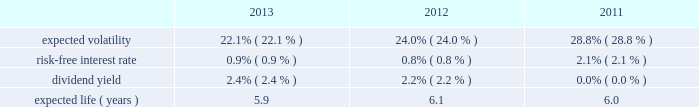Portion of the death benefits directly from the insurance company and the company receives the remainder of the death benefits .
It is currently expected that minimal cash payments will be required to fund these policies .
The net periodic pension cost for these split-dollar life insurance arrangements was $ 5 million for the years ended december 31 , 2013 , 2012 and 2011 .
The company has recorded a liability representing the actuarial present value of the future death benefits as of the employees 2019 expected retirement date of $ 51 million and $ 58 million as of december 31 , 2013 and december 31 , 2012 , respectively .
Deferred compensation plan the company amended and reinstated its deferred compensation plan ( 201cthe plan 201d ) effective june 1 , 2013 to reopen the plan to certain participants .
Under the plan , participating executives may elect to defer base salary and cash incentive compensation in excess of 401 ( k ) plan limitations .
Participants under the plan may choose to invest their deferred amounts in the same investment alternatives available under the company's 401 ( k ) plan .
The plan also allows for company matching contributions for the following : ( i ) the first 4% ( 4 % ) of compensation deferred under the plan , subject to a maximum of $ 50000 for board officers , ( ii ) lost matching amounts that would have been made under the 401 ( k ) plan if participants had not participated in the plan , and ( iii ) discretionary amounts as approved by the compensation and leadership committee of the board of directors .
Defined contribution plan the company and certain subsidiaries have various defined contribution plans , in which all eligible employees may participate .
In the u.s. , the 401 ( k ) plan is a contributory plan .
Matching contributions are based upon the amount of the employees 2019 contributions .
The company 2019s expenses for material defined contribution plans for the years ended december 31 , 2013 , 2012 and 2011 were $ 44 million , $ 42 million and $ 48 million , respectively .
Beginning january 1 , 2012 , the company may make an additional discretionary 401 ( k ) plan matching contribution to eligible employees .
For the years ended december 31 , 2013 and 2012 , the company made no discretionary matching contributions .
Share-based compensation plans and other incentive plans stock options , stock appreciation rights and employee stock purchase plan the company grants options to acquire shares of common stock to certain employees and to existing option holders of acquired companies in connection with the merging of option plans following an acquisition .
Each option granted and stock appreciation right has an exercise price of no less than 100% ( 100 % ) of the fair market value of the common stock on the date of the grant .
The awards have a contractual life of five to fifteen years and vest over two to four years .
Stock options and stock appreciation rights assumed or replaced with comparable stock options or stock appreciation rights in conjunction with a change in control of the company only become exercisable if the holder is also involuntarily terminated ( for a reason other than cause ) or quits for good reason within 24 months of a change in control .
The employee stock purchase plan allows eligible participants to purchase shares of the company 2019s common stock through payroll deductions of up to 20% ( 20 % ) of eligible compensation on an after-tax basis .
Plan participants cannot purchase more than $ 25000 of stock in any calendar year .
The price an employee pays per share is 85% ( 85 % ) of the lower of the fair market value of the company 2019s stock on the close of the first trading day or last trading day of the purchase period .
The plan has two purchase periods , the first from october 1 through march 31 and the second from april 1 through september 30 .
For the years ended december 31 , 2013 , 2012 and 2011 , employees purchased 1.5 million , 1.4 million and 2.2 million shares , respectively , at purchase prices of $ 43.02 and $ 50.47 , $ 34.52 and $ 42.96 , and $ 30.56 and $ 35.61 , respectively .
The company calculates the value of each employee stock option , estimated on the date of grant , using the black-scholes option pricing model .
The weighted-average estimated fair value of employee stock options granted during 2013 , 2012 and 2011 was $ 9.52 , $ 9.60 and $ 13.25 , respectively , using the following weighted-average assumptions: .
The company uses the implied volatility for traded options on the company 2019s stock as the expected volatility assumption required in the black-scholes model .
The selection of the implied volatility approach was based upon the availability of .
What was the average share price in 2012? 
Computations: (((34.52 + 42.96) + 2) / 2)
Answer: 39.74. 